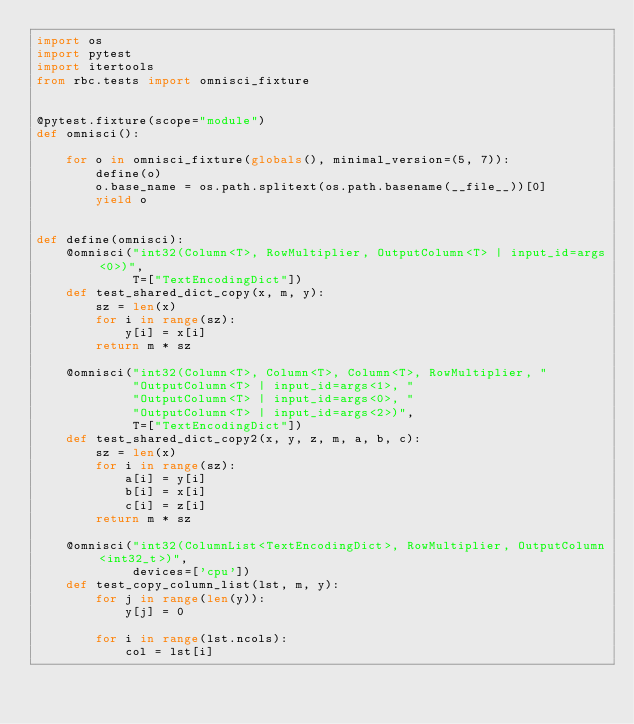<code> <loc_0><loc_0><loc_500><loc_500><_Python_>import os
import pytest
import itertools
from rbc.tests import omnisci_fixture


@pytest.fixture(scope="module")
def omnisci():

    for o in omnisci_fixture(globals(), minimal_version=(5, 7)):
        define(o)
        o.base_name = os.path.splitext(os.path.basename(__file__))[0]
        yield o


def define(omnisci):
    @omnisci("int32(Column<T>, RowMultiplier, OutputColumn<T> | input_id=args<0>)",
             T=["TextEncodingDict"])
    def test_shared_dict_copy(x, m, y):
        sz = len(x)
        for i in range(sz):
            y[i] = x[i]
        return m * sz

    @omnisci("int32(Column<T>, Column<T>, Column<T>, RowMultiplier, "
             "OutputColumn<T> | input_id=args<1>, "
             "OutputColumn<T> | input_id=args<0>, "
             "OutputColumn<T> | input_id=args<2>)",
             T=["TextEncodingDict"])
    def test_shared_dict_copy2(x, y, z, m, a, b, c):
        sz = len(x)
        for i in range(sz):
            a[i] = y[i]
            b[i] = x[i]
            c[i] = z[i]
        return m * sz

    @omnisci("int32(ColumnList<TextEncodingDict>, RowMultiplier, OutputColumn<int32_t>)",
             devices=['cpu'])
    def test_copy_column_list(lst, m, y):
        for j in range(len(y)):
            y[j] = 0

        for i in range(lst.ncols):
            col = lst[i]</code> 